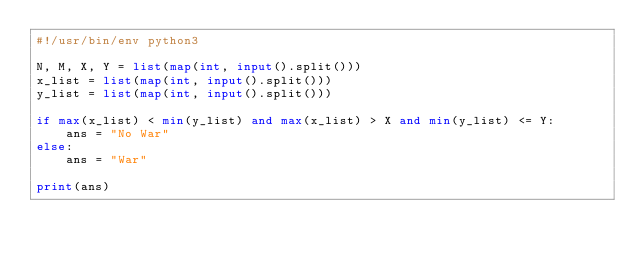<code> <loc_0><loc_0><loc_500><loc_500><_Python_>#!/usr/bin/env python3

N, M, X, Y = list(map(int, input().split()))
x_list = list(map(int, input().split()))
y_list = list(map(int, input().split()))

if max(x_list) < min(y_list) and max(x_list) > X and min(y_list) <= Y:
    ans = "No War"
else:
    ans = "War"

print(ans)
</code> 